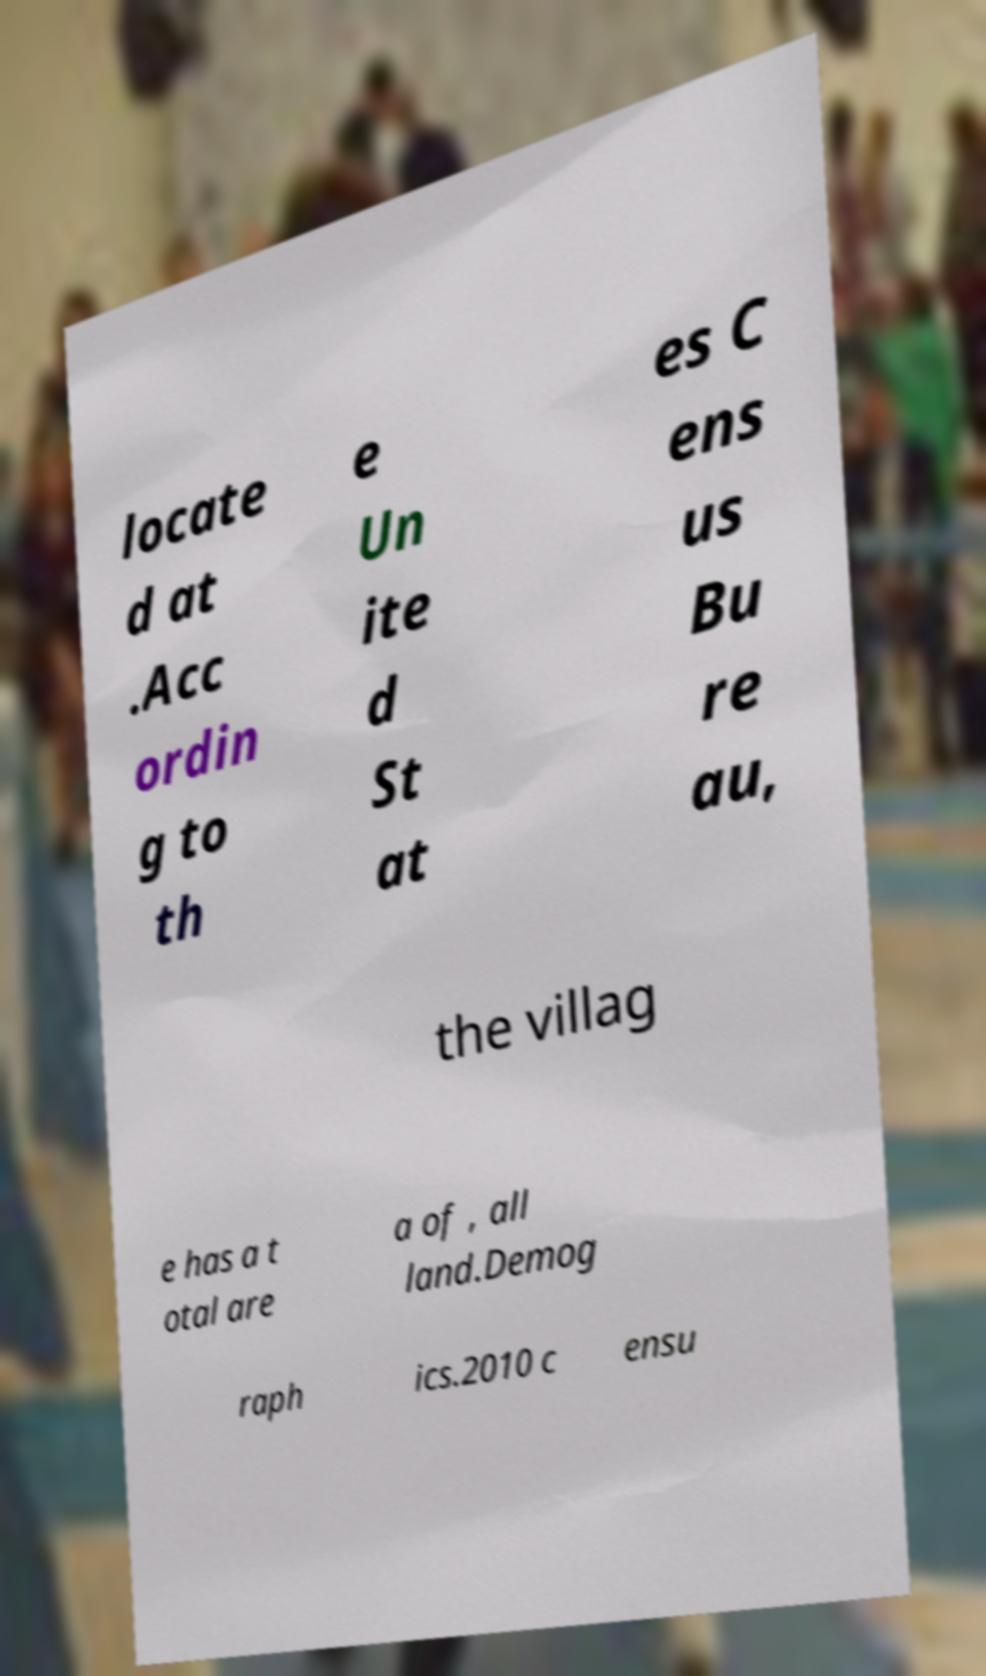Please read and relay the text visible in this image. What does it say? locate d at .Acc ordin g to th e Un ite d St at es C ens us Bu re au, the villag e has a t otal are a of , all land.Demog raph ics.2010 c ensu 